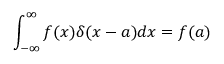<formula> <loc_0><loc_0><loc_500><loc_500>\int _ { - \infty } ^ { \infty } f ( x ) \delta ( x - a ) d x = f ( a )</formula> 